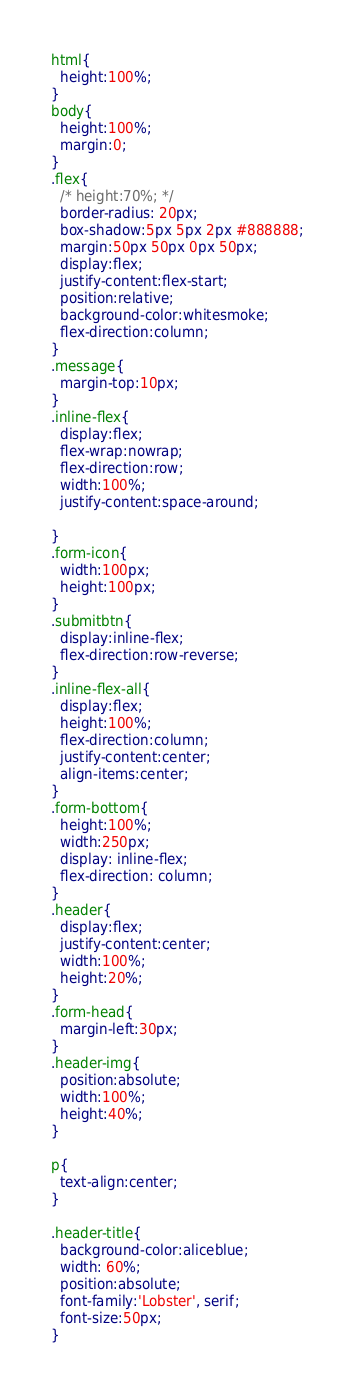<code> <loc_0><loc_0><loc_500><loc_500><_CSS_>html{
  height:100%;
}
body{
  height:100%;
  margin:0;
}
.flex{
  /* height:70%; */
  border-radius: 20px;
  box-shadow:5px 5px 2px #888888;
  margin:50px 50px 0px 50px;
  display:flex;
  justify-content:flex-start;
  position:relative;
  background-color:whitesmoke;
  flex-direction:column;
}
.message{
  margin-top:10px;
}
.inline-flex{
  display:flex;
  flex-wrap:nowrap;
  flex-direction:row;
  width:100%;
  justify-content:space-around;

}
.form-icon{
  width:100px;
  height:100px;
}
.submitbtn{
  display:inline-flex;
  flex-direction:row-reverse;
}
.inline-flex-all{
  display:flex;
  height:100%;
  flex-direction:column;
  justify-content:center;
  align-items:center;
}
.form-bottom{
  height:100%;
  width:250px;
  display: inline-flex;
  flex-direction: column;
}
.header{
  display:flex;
  justify-content:center;
  width:100%;
  height:20%;
}
.form-head{
  margin-left:30px;
}
.header-img{
  position:absolute;
  width:100%;
  height:40%;
}

p{
  text-align:center;
}

.header-title{
  background-color:aliceblue;
  width: 60%;
  position:absolute;
  font-family:'Lobster', serif;
  font-size:50px;
}
</code> 